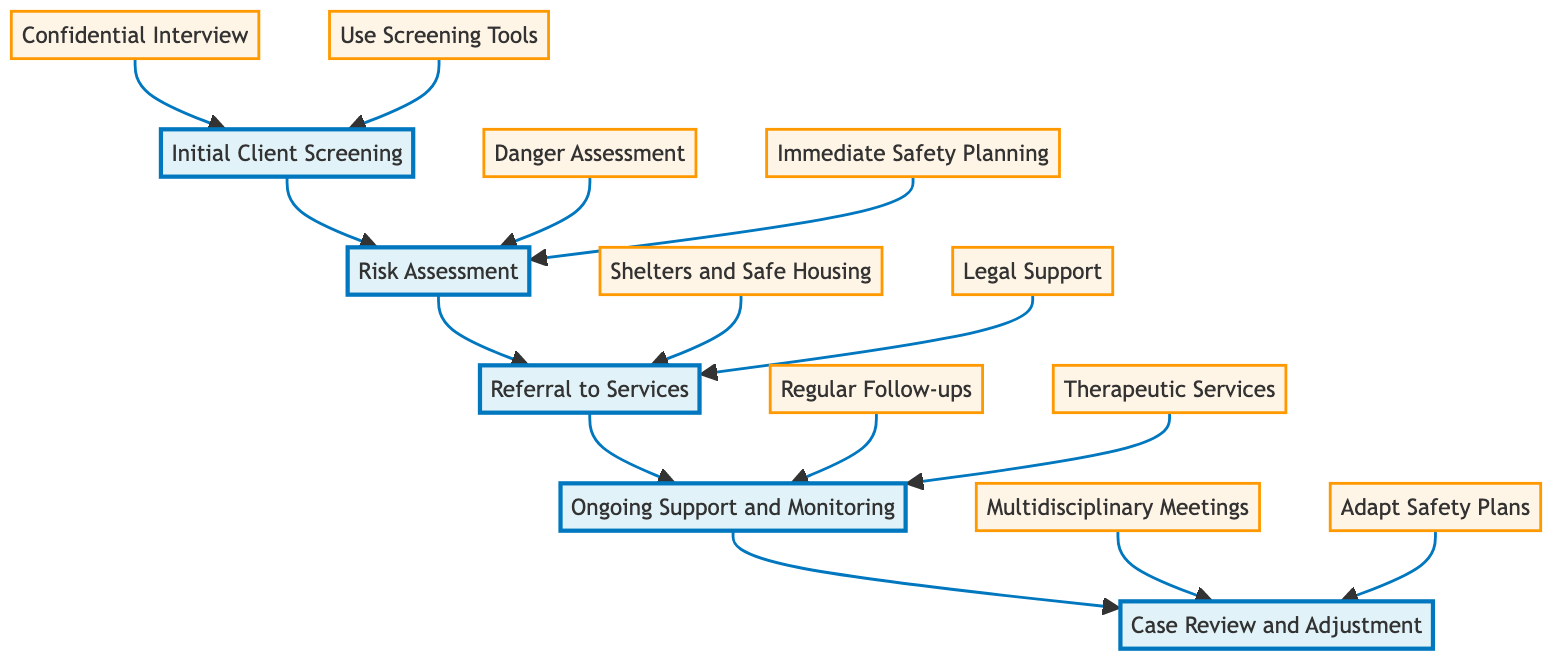What is the first step in the intervention timeline? The diagram indicates that the first step is "Initial Client Screening," which is the first node in the flowchart leading to subsequent steps.
Answer: Initial Client Screening How many main steps are there in the intervention timeline? By counting the nodes, there are five main steps depicted in the flowchart: Initial Client Screening, Risk Assessment, Referral to Services, Ongoing Support and Monitoring, and Case Review and Adjustment.
Answer: 5 What are the two actions under "Referral to Services"? The flowchart lists two actions stemming from the "Referral to Services" step: "Shelters and Safe Housing" and "Legal Support." These actions are shown as separate nodes branching from the main step.
Answer: Shelters and Safe Housing, Legal Support Which step comes after "Risk Assessment"? According to the flowchart, the step following "Risk Assessment" is "Referral to Services," as indicated by the directed arrow connecting these two steps in the diagram.
Answer: Referral to Services What type of meetings are held during the "Case Review and Adjustment" step? The diagram specifies that "Multidisciplinary Meetings" are conducted during the "Case Review and Adjustment" step, indicating collaboration among various professionals.
Answer: Multidisciplinary Meetings Which task is associated with "Ongoing Support and Monitoring"? The flowchart associates two tasks with "Ongoing Support and Monitoring": "Regular Follow-ups" and "Therapeutic Services," which provide ongoing client care.
Answer: Regular Follow-ups, Therapeutic Services What is the main purpose of the "Risk Assessment" step? The purpose of the "Risk Assessment" step, as described in the diagram, is to evaluate the level of risk for clients identified as potentially experiencing domestic abuse, informing subsequent actions.
Answer: Evaluating the level of risk How are clients referred to legal support according to the diagram? Clients are referred to legal support through the action "Legal Support" within the "Referral to Services" step, which directly connects clients to necessary legal resources.
Answer: Legal Support What is the final step in this intervention diagram? The final step in the intervention timeline is "Case Review and Adjustment," representing the conclusion of the main intervention process and indicating the need for ongoing evaluation.
Answer: Case Review and Adjustment 